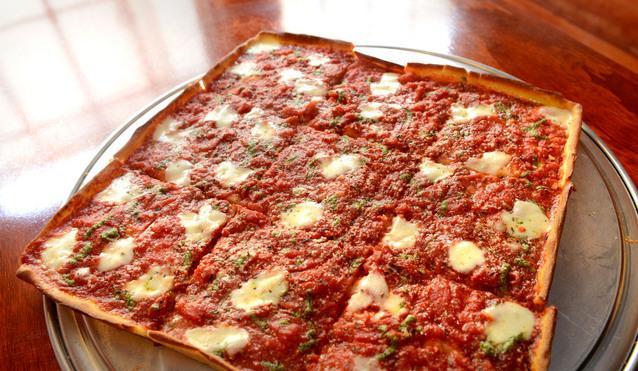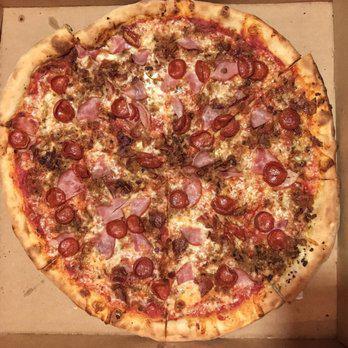The first image is the image on the left, the second image is the image on the right. Considering the images on both sides, is "The left image shows at least one single slice of pizza." valid? Answer yes or no. No. The first image is the image on the left, the second image is the image on the right. For the images shown, is this caption "The right image contains a sliced round pizza with no slices missing, and the left image contains at least one wedge-shaped slice of pizza on white paper." true? Answer yes or no. No. 